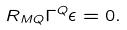Convert formula to latex. <formula><loc_0><loc_0><loc_500><loc_500>R _ { M Q } \Gamma ^ { Q } \epsilon = 0 .</formula> 